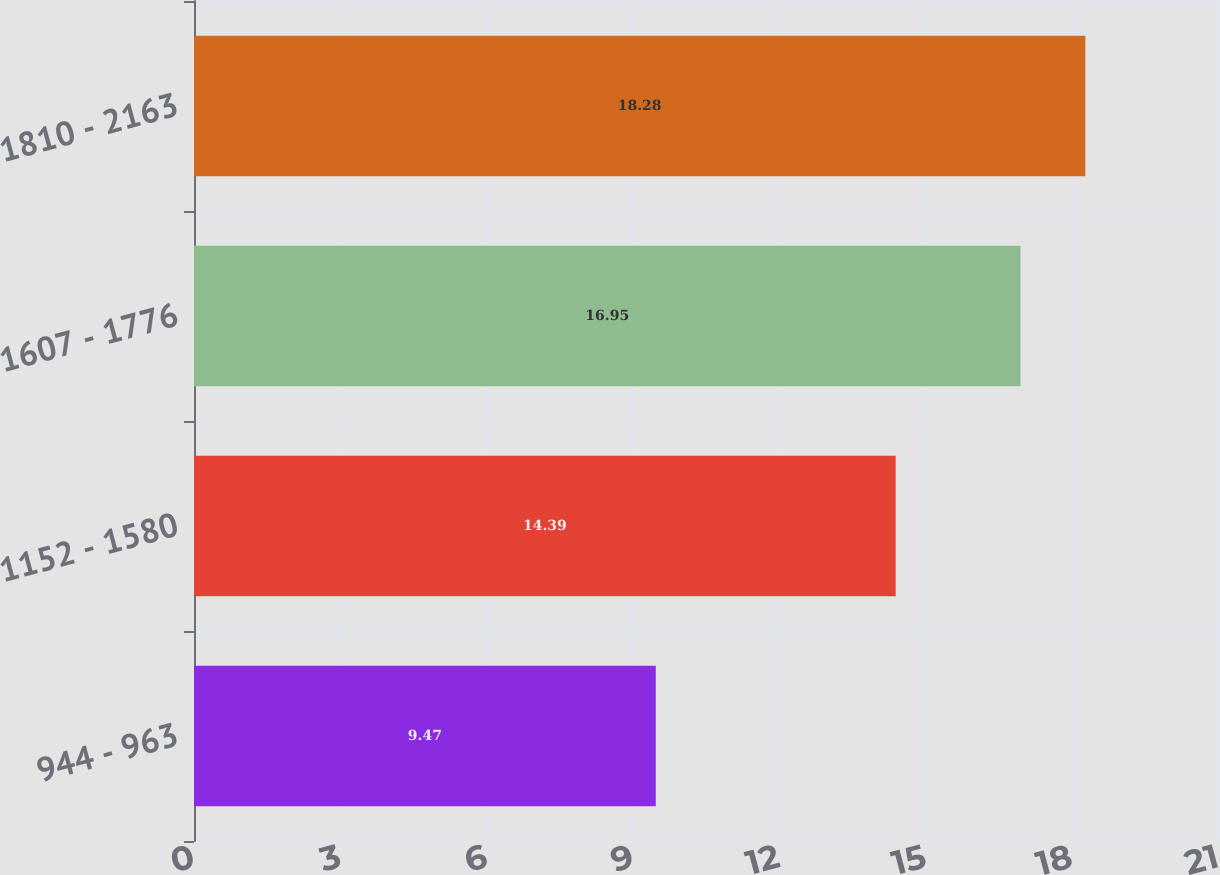Convert chart. <chart><loc_0><loc_0><loc_500><loc_500><bar_chart><fcel>944 - 963<fcel>1152 - 1580<fcel>1607 - 1776<fcel>1810 - 2163<nl><fcel>9.47<fcel>14.39<fcel>16.95<fcel>18.28<nl></chart> 